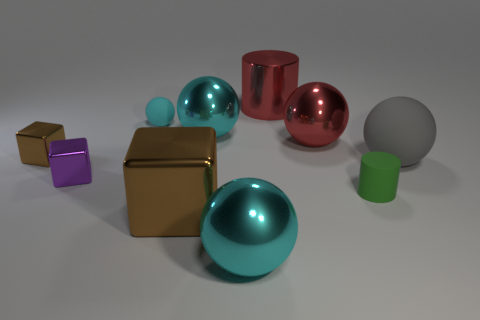What is the color of the large shiny sphere on the right side of the large red thing that is behind the small cyan sphere?
Ensure brevity in your answer.  Red. There is a sphere that is in front of the cylinder in front of the brown metal cube that is behind the purple object; what is its material?
Your answer should be very brief. Metal. What number of gray spheres have the same size as the red cylinder?
Keep it short and to the point. 1. What is the material of the small thing that is on the right side of the small purple thing and behind the large gray rubber ball?
Offer a very short reply. Rubber. There is a purple metal block; what number of tiny blocks are left of it?
Your response must be concise. 1. There is a small brown shiny thing; is its shape the same as the big red shiny thing in front of the small cyan matte object?
Provide a succinct answer. No. Is there a small purple metallic object of the same shape as the small cyan thing?
Provide a short and direct response. No. There is a tiny metal object that is to the right of the brown metal cube that is behind the big gray rubber object; what is its shape?
Your answer should be compact. Cube. The brown metallic thing in front of the purple metal thing has what shape?
Your answer should be very brief. Cube. There is a matte thing that is left of the big shiny cylinder; is its color the same as the small rubber object that is in front of the tiny purple thing?
Your response must be concise. No. 